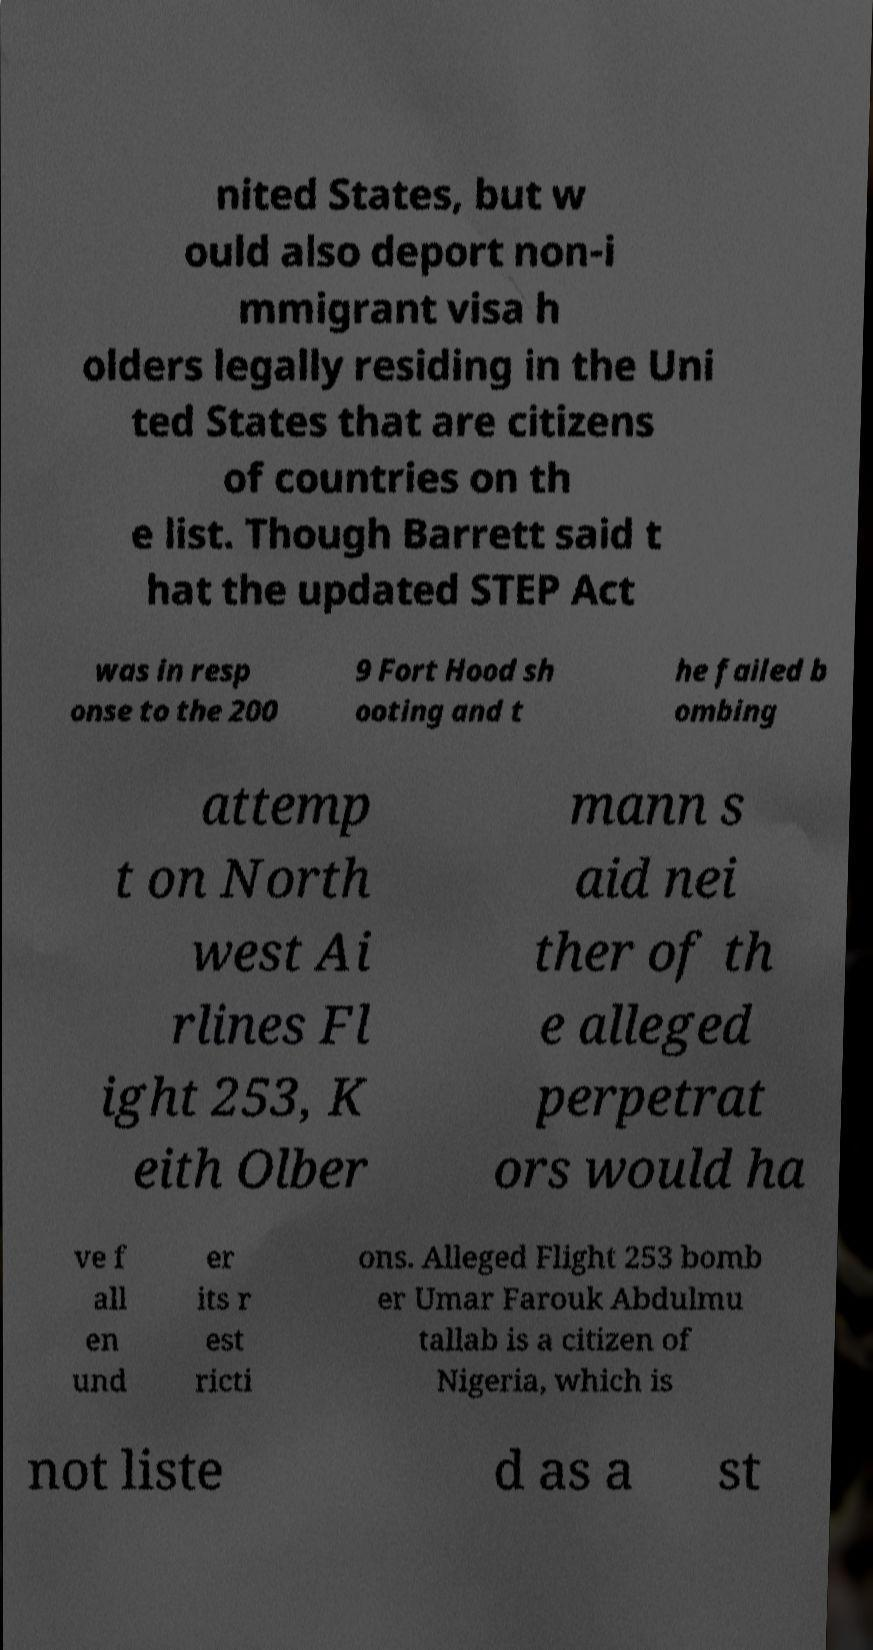For documentation purposes, I need the text within this image transcribed. Could you provide that? nited States, but w ould also deport non-i mmigrant visa h olders legally residing in the Uni ted States that are citizens of countries on th e list. Though Barrett said t hat the updated STEP Act was in resp onse to the 200 9 Fort Hood sh ooting and t he failed b ombing attemp t on North west Ai rlines Fl ight 253, K eith Olber mann s aid nei ther of th e alleged perpetrat ors would ha ve f all en und er its r est ricti ons. Alleged Flight 253 bomb er Umar Farouk Abdulmu tallab is a citizen of Nigeria, which is not liste d as a st 